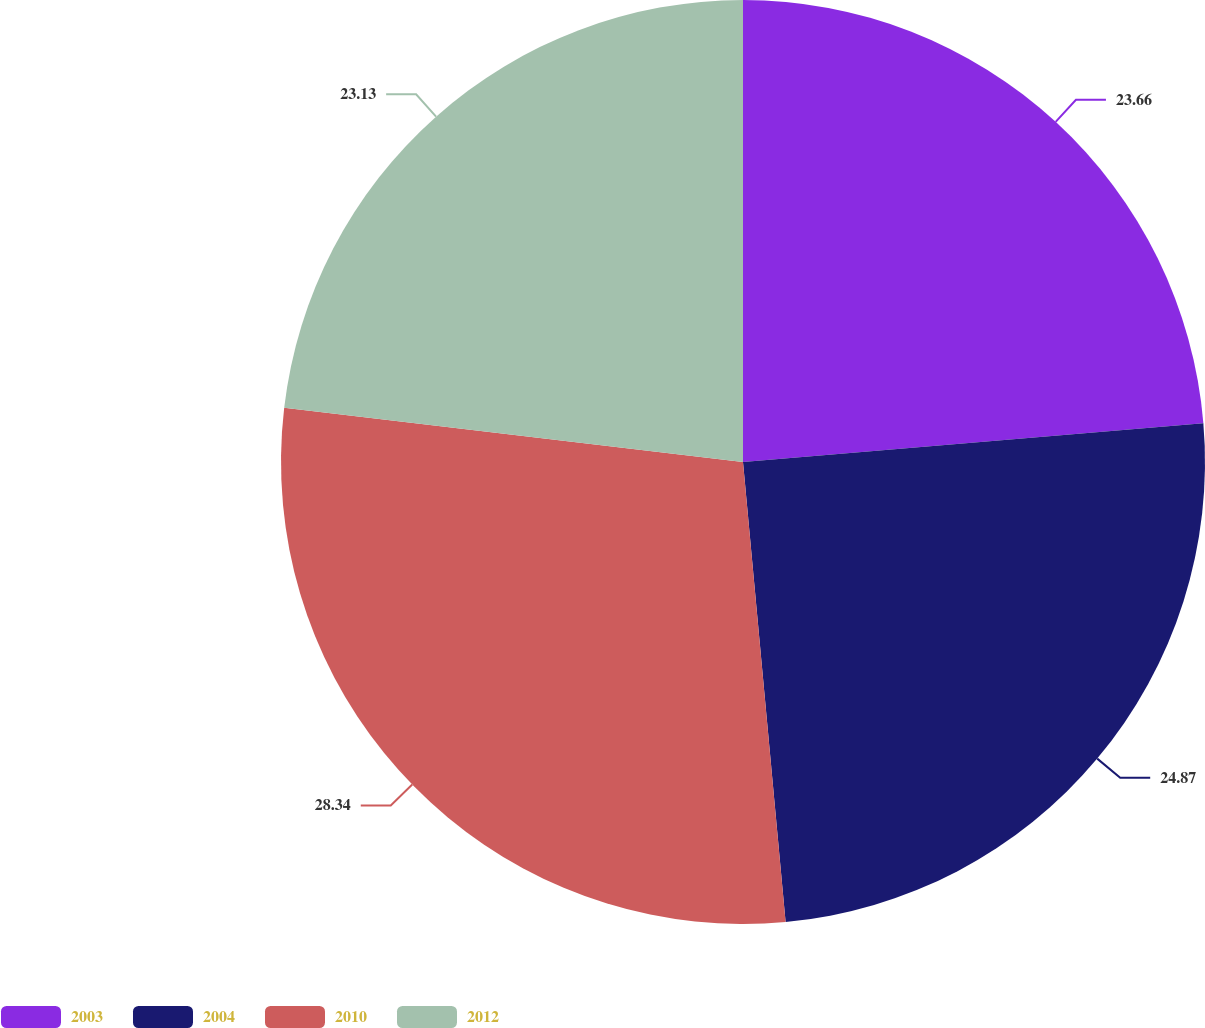Convert chart to OTSL. <chart><loc_0><loc_0><loc_500><loc_500><pie_chart><fcel>2003<fcel>2004<fcel>2010<fcel>2012<nl><fcel>23.66%<fcel>24.87%<fcel>28.34%<fcel>23.13%<nl></chart> 